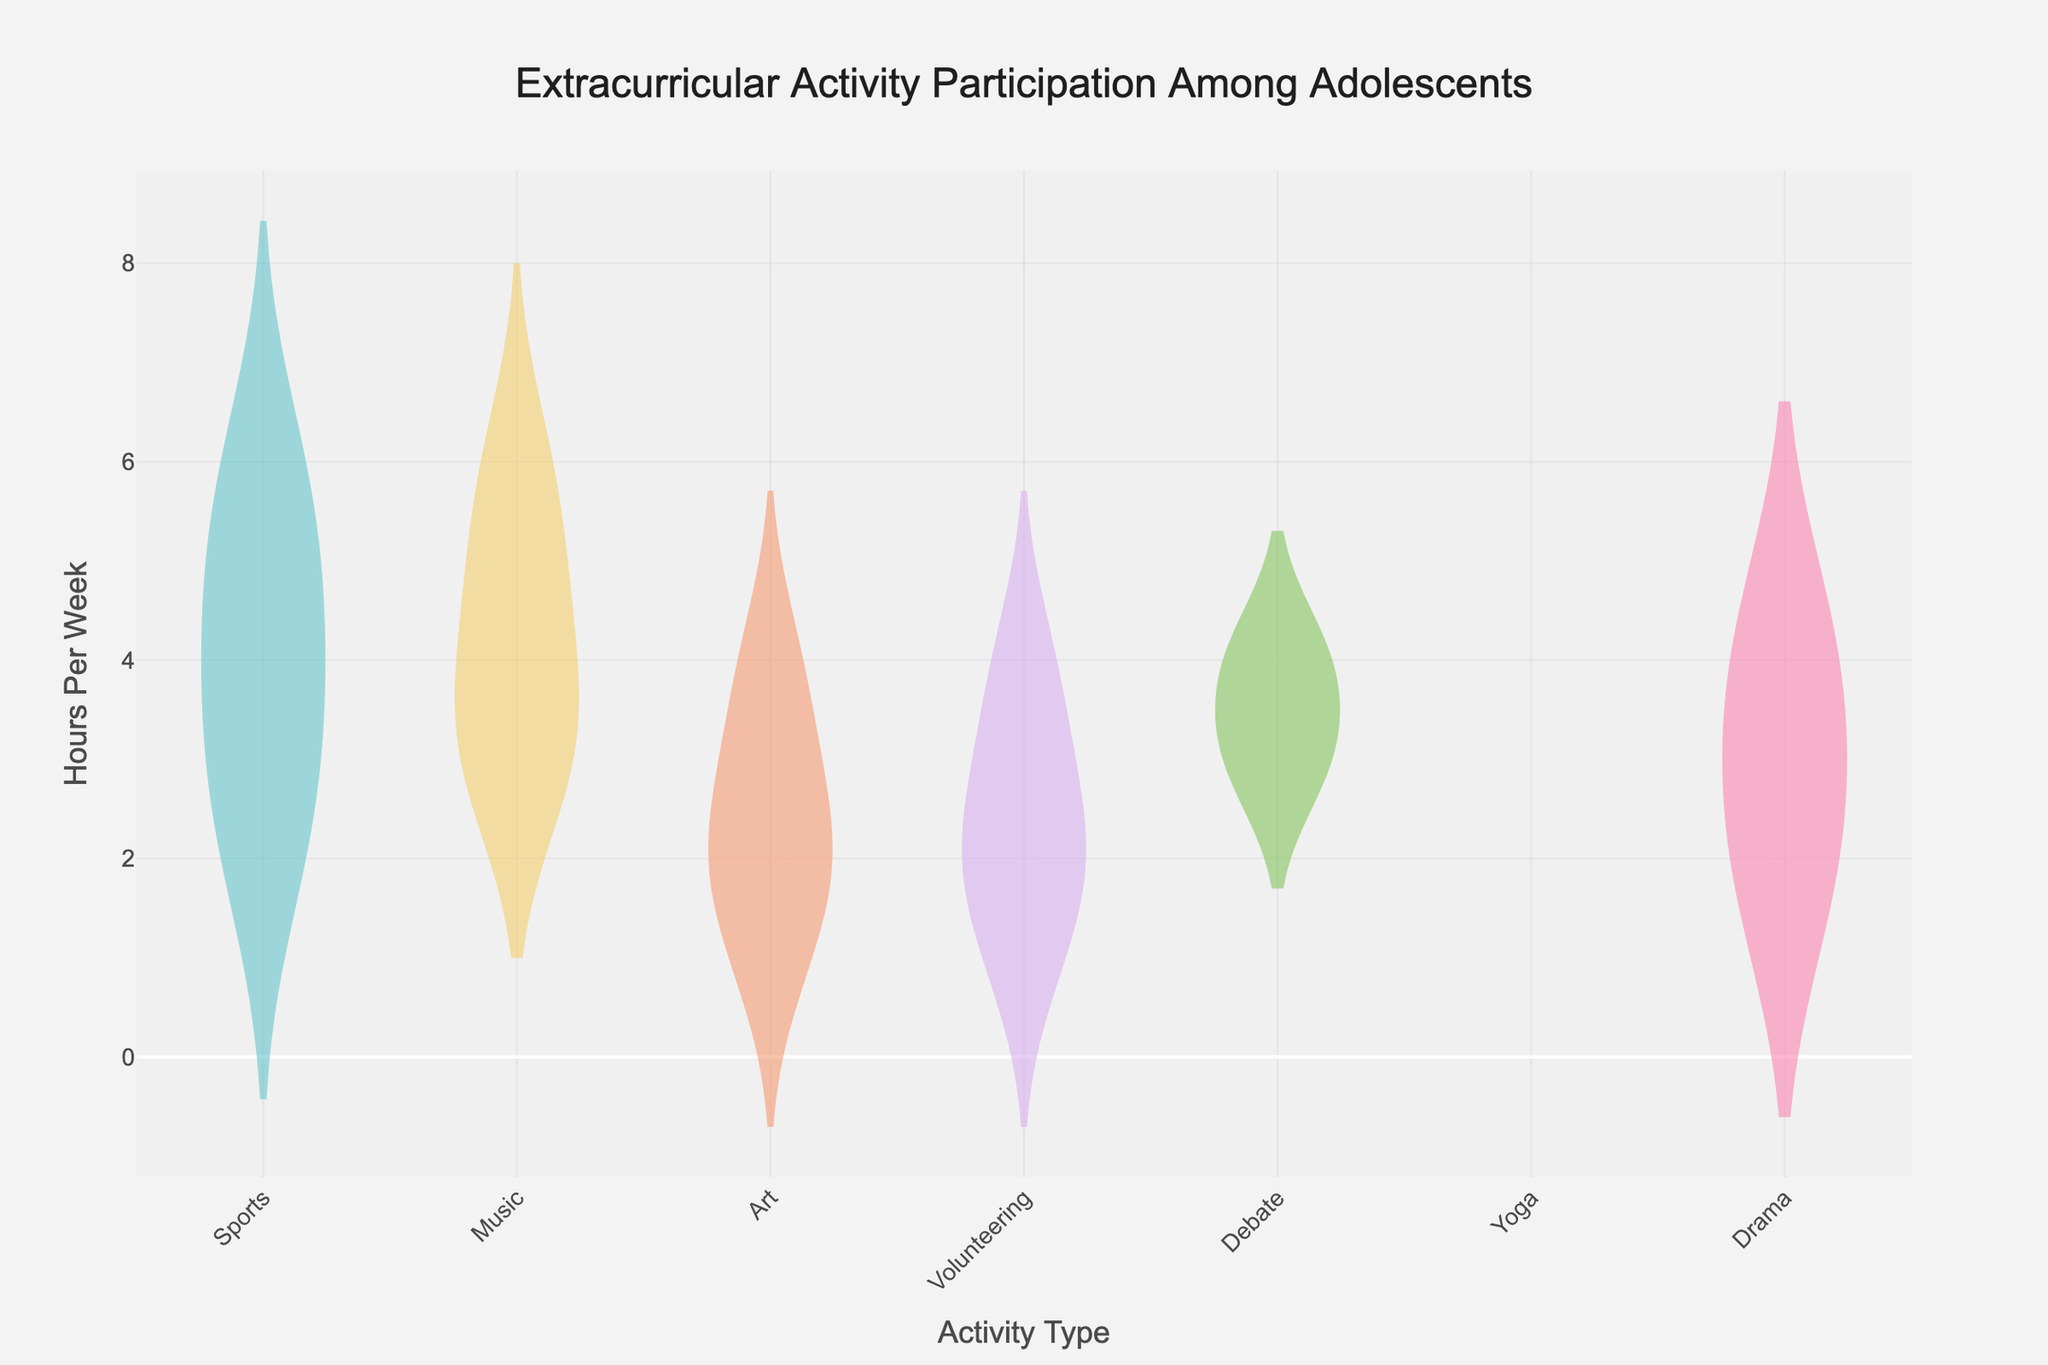what is the title of the plot? The title is displayed prominently at the top of the violin chart.
Answer: Extracurricular Activity Participation Among Adolescents what does the x-axis represent? The x-axis labels are positioned along the horizontal axis and represent different types of activities.
Answer: Activity Type how many activities are presented in the plot? Count the number of unique activity names along the x-axis.
Answer: Seven which activity has the highest median hours per week? Examine the median lines (bold horizontal line in the box part of the violin plot) for each activity and identify the highest one.
Answer: Music which age group has the highest participation in sports? Refer to the spread and concentration of data points within the "Sports" violin plot across different ages, identifying which age group appears most frequently.
Answer: Age 15 how does the distribution of hours per week for music compare to sports? Compare the width and density of the violin sections for "Music" and "Sports" along the y-axis.
Answer: Music has higher central values but less spread what is the mean number of hours per week for volunteering? Look at the mean line (thin dashed horizontal line) within the violin plot for "Volunteering."
Answer: Approximately 2 hours which activity shows the highest variability in participation? Determine this by observing the activity with the widest spread of the violin plot.
Answer: Sports are there any outliers in the distribution for art? Outliers are indicated by points outside the main body of the violin plot for "Art."
Answer: No which activity has the least spread in participation hours? The least spread is indicated by the narrowest violin plot along the y-axis.
Answer: Drama 